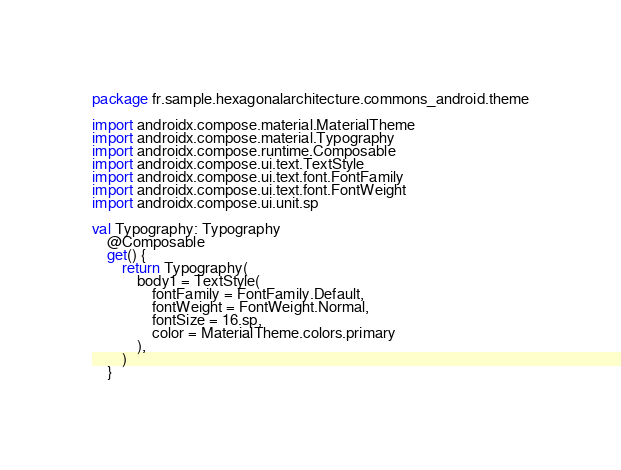Convert code to text. <code><loc_0><loc_0><loc_500><loc_500><_Kotlin_>package fr.sample.hexagonalarchitecture.commons_android.theme

import androidx.compose.material.MaterialTheme
import androidx.compose.material.Typography
import androidx.compose.runtime.Composable
import androidx.compose.ui.text.TextStyle
import androidx.compose.ui.text.font.FontFamily
import androidx.compose.ui.text.font.FontWeight
import androidx.compose.ui.unit.sp

val Typography: Typography
    @Composable
    get() {
        return Typography(
            body1 = TextStyle(
                fontFamily = FontFamily.Default,
                fontWeight = FontWeight.Normal,
                fontSize = 16.sp,
                color = MaterialTheme.colors.primary
            ),
        )
    }
</code> 